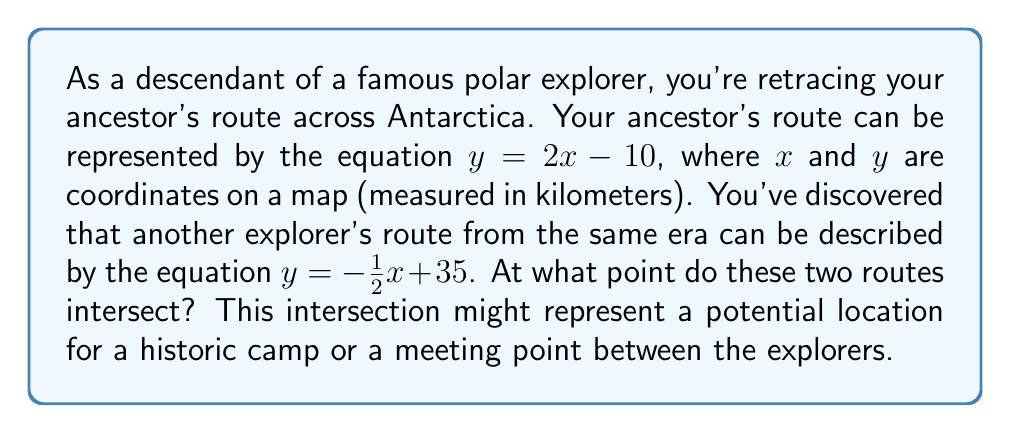Help me with this question. To find the intersection point of these two routes, we need to solve the system of linear equations:

$$\begin{cases}
y = 2x - 10 \\
y = -\frac{1}{2}x + 35
\end{cases}$$

Let's solve this step-by-step:

1) Since both equations are equal to $y$, we can set them equal to each other:

   $2x - 10 = -\frac{1}{2}x + 35$

2) Add $\frac{1}{2}x$ to both sides:

   $\frac{5}{2}x - 10 = 35$

3) Add 10 to both sides:

   $\frac{5}{2}x = 45$

4) Multiply both sides by $\frac{2}{5}$:

   $x = 18$

5) Now that we know $x$, we can substitute this value into either of the original equations to find $y$. Let's use the first equation:

   $y = 2x - 10$
   $y = 2(18) - 10$
   $y = 36 - 10 = 26$

Therefore, the intersection point is at $(18, 26)$.
Answer: The two explorer routes intersect at the point $(18, 26)$, which represents 18 km east and 26 km north from the origin on the map. 